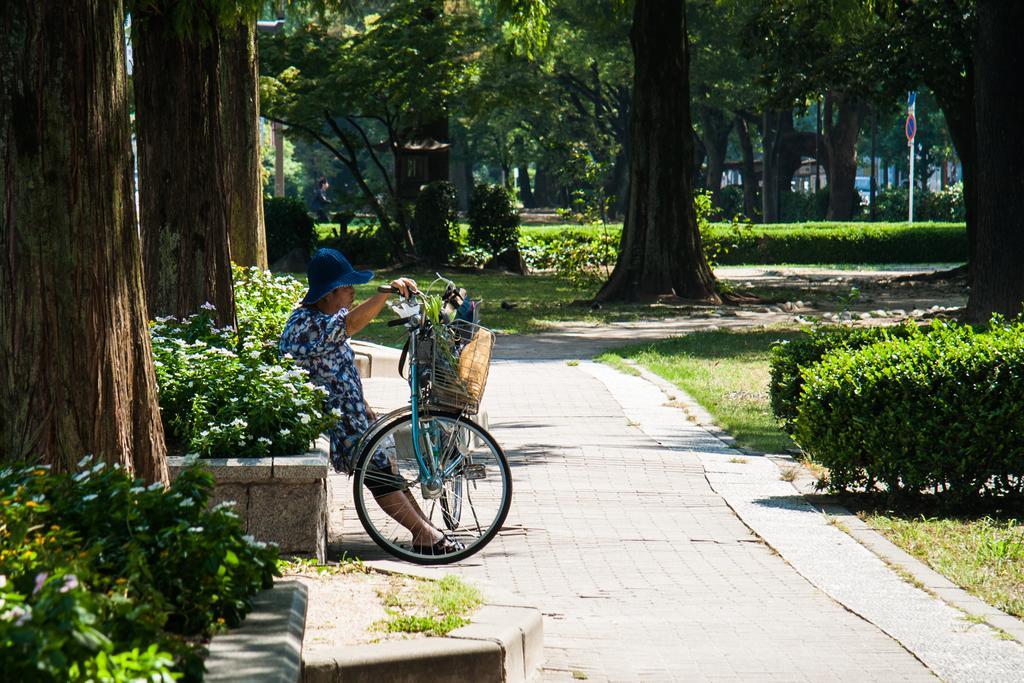Could you give a brief overview of what you see in this image? In this image we can see a person wearing hat is sitting on a wall and holding a bicycle with his hand placed on the ground. In the background, we can see a person standing on ground, poles and sign board, a group of flowers on plants and a group of trees. 